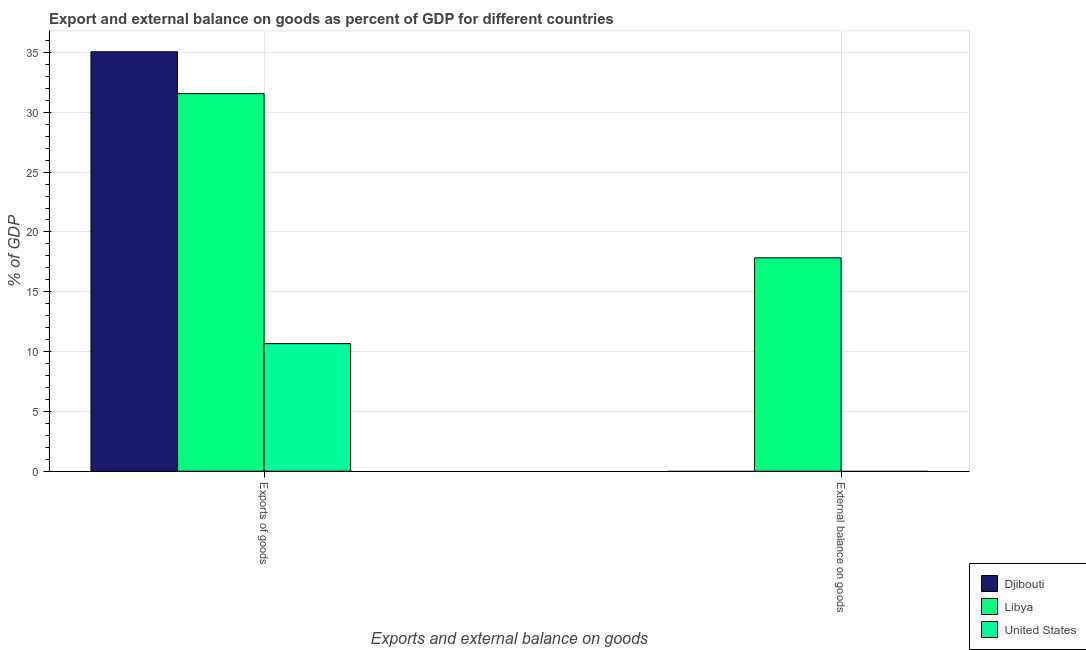Are the number of bars on each tick of the X-axis equal?
Give a very brief answer. No. How many bars are there on the 1st tick from the right?
Provide a short and direct response. 1. What is the label of the 1st group of bars from the left?
Ensure brevity in your answer.  Exports of goods. What is the external balance on goods as percentage of gdp in Djibouti?
Your answer should be compact. 0. Across all countries, what is the maximum export of goods as percentage of gdp?
Offer a very short reply. 35.06. In which country was the external balance on goods as percentage of gdp maximum?
Provide a succinct answer. Libya. What is the total export of goods as percentage of gdp in the graph?
Offer a very short reply. 77.28. What is the difference between the export of goods as percentage of gdp in Libya and that in United States?
Make the answer very short. 20.89. What is the difference between the external balance on goods as percentage of gdp in Libya and the export of goods as percentage of gdp in Djibouti?
Offer a terse response. -17.22. What is the average external balance on goods as percentage of gdp per country?
Offer a terse response. 5.94. What is the difference between the external balance on goods as percentage of gdp and export of goods as percentage of gdp in Libya?
Your answer should be compact. -13.72. In how many countries, is the external balance on goods as percentage of gdp greater than 33 %?
Provide a short and direct response. 0. What is the ratio of the export of goods as percentage of gdp in United States to that in Libya?
Your answer should be very brief. 0.34. Is the export of goods as percentage of gdp in Djibouti less than that in Libya?
Keep it short and to the point. No. In how many countries, is the export of goods as percentage of gdp greater than the average export of goods as percentage of gdp taken over all countries?
Offer a very short reply. 2. How many bars are there?
Give a very brief answer. 4. Are all the bars in the graph horizontal?
Your answer should be compact. No. Are the values on the major ticks of Y-axis written in scientific E-notation?
Offer a terse response. No. Does the graph contain any zero values?
Offer a very short reply. Yes. Where does the legend appear in the graph?
Provide a succinct answer. Bottom right. How many legend labels are there?
Your answer should be very brief. 3. What is the title of the graph?
Offer a terse response. Export and external balance on goods as percent of GDP for different countries. What is the label or title of the X-axis?
Your answer should be very brief. Exports and external balance on goods. What is the label or title of the Y-axis?
Provide a short and direct response. % of GDP. What is the % of GDP of Djibouti in Exports of goods?
Your answer should be compact. 35.06. What is the % of GDP of Libya in Exports of goods?
Ensure brevity in your answer.  31.56. What is the % of GDP in United States in Exports of goods?
Offer a very short reply. 10.66. What is the % of GDP of Djibouti in External balance on goods?
Make the answer very short. 0. What is the % of GDP in Libya in External balance on goods?
Your answer should be compact. 17.83. What is the % of GDP of United States in External balance on goods?
Provide a short and direct response. 0. Across all Exports and external balance on goods, what is the maximum % of GDP of Djibouti?
Your answer should be compact. 35.06. Across all Exports and external balance on goods, what is the maximum % of GDP in Libya?
Provide a short and direct response. 31.56. Across all Exports and external balance on goods, what is the maximum % of GDP of United States?
Your answer should be compact. 10.66. Across all Exports and external balance on goods, what is the minimum % of GDP in Libya?
Offer a very short reply. 17.83. Across all Exports and external balance on goods, what is the minimum % of GDP in United States?
Give a very brief answer. 0. What is the total % of GDP in Djibouti in the graph?
Offer a terse response. 35.06. What is the total % of GDP of Libya in the graph?
Provide a short and direct response. 49.39. What is the total % of GDP of United States in the graph?
Ensure brevity in your answer.  10.66. What is the difference between the % of GDP in Libya in Exports of goods and that in External balance on goods?
Offer a very short reply. 13.72. What is the difference between the % of GDP in Djibouti in Exports of goods and the % of GDP in Libya in External balance on goods?
Ensure brevity in your answer.  17.22. What is the average % of GDP of Djibouti per Exports and external balance on goods?
Your response must be concise. 17.53. What is the average % of GDP of Libya per Exports and external balance on goods?
Your answer should be compact. 24.7. What is the average % of GDP of United States per Exports and external balance on goods?
Make the answer very short. 5.33. What is the difference between the % of GDP in Djibouti and % of GDP in Libya in Exports of goods?
Ensure brevity in your answer.  3.5. What is the difference between the % of GDP of Djibouti and % of GDP of United States in Exports of goods?
Your answer should be compact. 24.39. What is the difference between the % of GDP in Libya and % of GDP in United States in Exports of goods?
Give a very brief answer. 20.89. What is the ratio of the % of GDP in Libya in Exports of goods to that in External balance on goods?
Give a very brief answer. 1.77. What is the difference between the highest and the second highest % of GDP in Libya?
Keep it short and to the point. 13.72. What is the difference between the highest and the lowest % of GDP in Djibouti?
Offer a very short reply. 35.06. What is the difference between the highest and the lowest % of GDP of Libya?
Provide a short and direct response. 13.72. What is the difference between the highest and the lowest % of GDP of United States?
Provide a short and direct response. 10.66. 